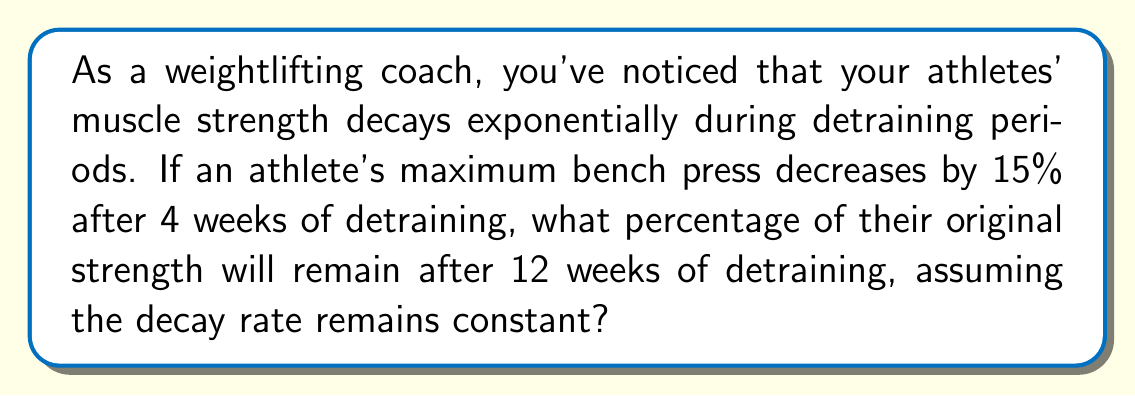Help me with this question. Let's approach this step-by-step using exponential decay:

1) Let $S(t)$ be the strength at time $t$ (in weeks), and $S_0$ be the initial strength.

2) The exponential decay formula is:
   $$S(t) = S_0 \cdot (1-r)^t$$
   where $r$ is the decay rate per week.

3) After 4 weeks, we know that 85% of the strength remains. So:
   $$0.85 = (1-r)^4$$

4) To find $r$, we solve:
   $$(1-r)^4 = 0.85$$
   $$1-r = 0.85^{\frac{1}{4}} \approx 0.9608$$
   $$r \approx 0.0392$$ or about 3.92% per week

5) Now, we can use this rate to find the strength after 12 weeks:
   $$S(12) = S_0 \cdot (1-0.0392)^{12}$$
   $$S(12) = S_0 \cdot (0.9608)^{12}$$
   $$S(12) = S_0 \cdot 0.6166$$

6) This means after 12 weeks, about 61.66% of the original strength remains.
Answer: Approximately 61.66% of the original strength will remain after 12 weeks of detraining. 